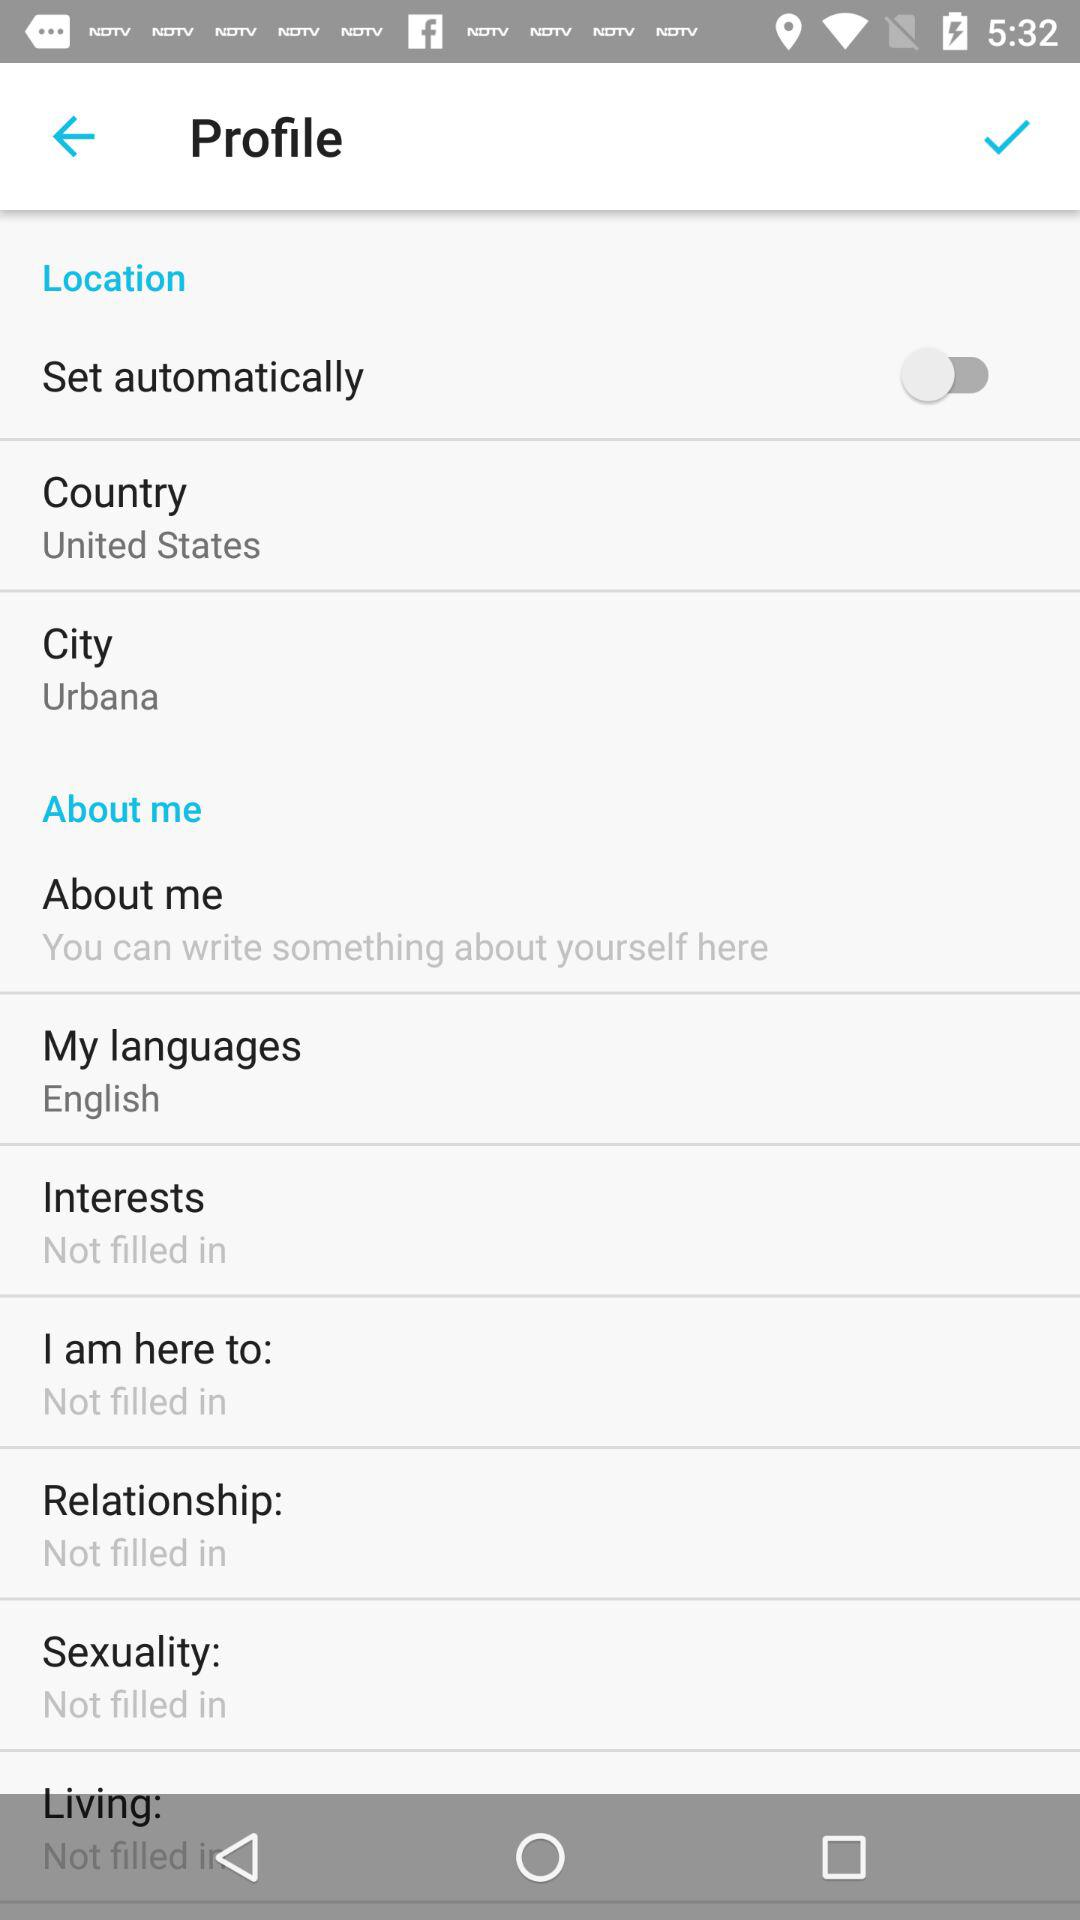Are "Interests" filled or not? "Interests" are not filled. 